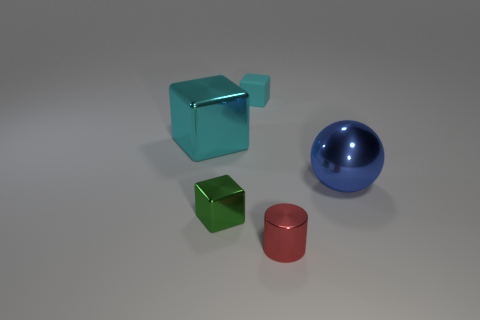Subtract all metallic cubes. How many cubes are left? 1 Subtract all green blocks. How many blocks are left? 2 Add 2 metal cylinders. How many objects exist? 7 Subtract all gray cylinders. How many cyan cubes are left? 2 Subtract 3 cubes. How many cubes are left? 0 Subtract all cylinders. How many objects are left? 4 Add 4 green metal objects. How many green metal objects are left? 5 Add 4 blue shiny balls. How many blue shiny balls exist? 5 Subtract 1 cyan cubes. How many objects are left? 4 Subtract all gray blocks. Subtract all yellow spheres. How many blocks are left? 3 